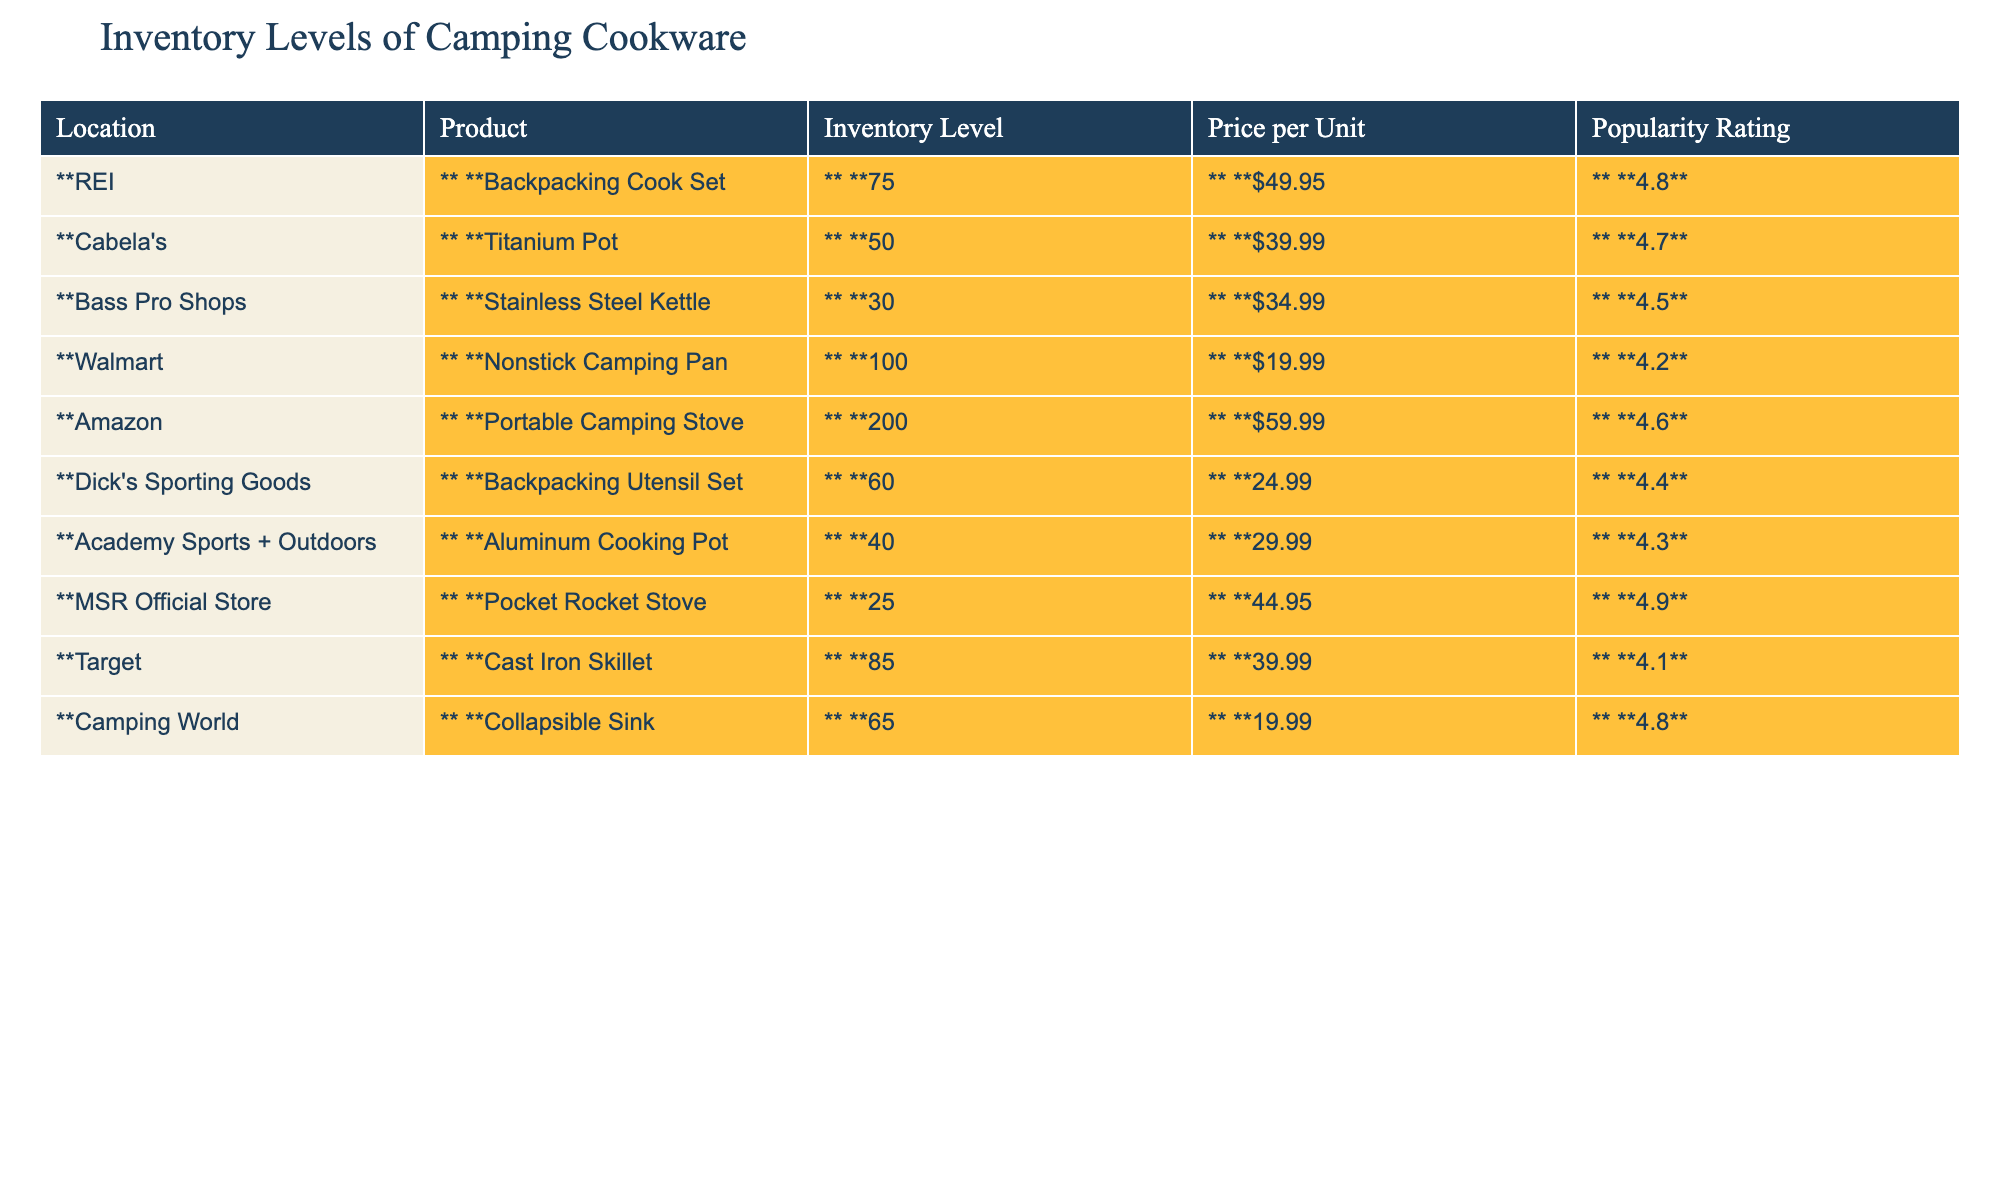What is the inventory level of the Portable Camping Stove at Amazon? The table shows that the inventory level for the Portable Camping Stove at Amazon is listed under the corresponding location and product. By checking the row for Amazon and the Portable Camping Stove, the inventory level is 200.
Answer: 200 Which store has the highest inventory level of cooking cookware? By examining the inventory levels across all stores in the table, I can see that Amazon has the highest inventory level of 200.
Answer: Amazon What is the price of the Backpacking Cook Set at REI? The table lists the price for the Backpacking Cook Set specifically for REI. By reading that row, I find the price is $49.95.
Answer: $49.95 How many more Stainless Steel Kettles does Bass Pro Shops have compared to the Titanium Pot at Cabela's? I will look at the inventory levels for both the Stainless Steel Kettle at Bass Pro Shops (30) and the Titanium Pot at Cabela's (50). The difference is calculated as 50 - 30 = 20.
Answer: 20 What is the popularity rating of the Nonstick Camping Pan at Walmart? The table indicates the popularity rating directly next to the product in the Walmart row, which shows it is rated 4.2.
Answer: 4.2 Which product has the lowest inventory level and what is that level? I need to find the product with the lowest inventory by reviewing each product's inventory. The lowest inventory level is 25 for the Pocket Rocket Stove at MSR Official Store.
Answer: 25 What is the average price of all products listed in the table? To find the average price, I need to sum all the prices and divide by the number of products. The total price sums up to $49.95 + $39.99 + $34.99 + $19.99 + $59.99 + $24.99 + $29.99 + $44.95 + $39.99 + $19.99 = $413.83. Then, dividing $413.83 by 10 (the number of products) gives me an average price of $41.38.
Answer: $41.38 How does the popularity rating of the Aluminum Cooking Pot compare to the Backpacking Utensil Set? I compare the popularity ratings: Aluminum Cooking Pot is 4.3 and Backpacking Utensil Set is 4.4. The Backpacking Utensil Set has a higher rating by 0.1.
Answer: Backpacking Utensil Set is higher by 0.1 Is there a product with a popularity rating of 4.9? I can check the popularity ratings for all products listed in the table. The Pocket Rocket Stove at MSR Official Store has a rating of 4.9.
Answer: Yes Which store sells the most inexpensive camping cookware item and what is that price? I need to compare all prices listed for the products. The Nonstick Camping Pan at Walmart is priced at $19.99, which is the lowest when compared to other items.
Answer: $19.99 What is the total inventory level of cooking cookware at Academy Sports + Outdoors and Target combined? I will look up the inventory levels for Academy Sports + Outdoors (40) and Target (85) and then add them together: 40 + 85 = 125.
Answer: 125 